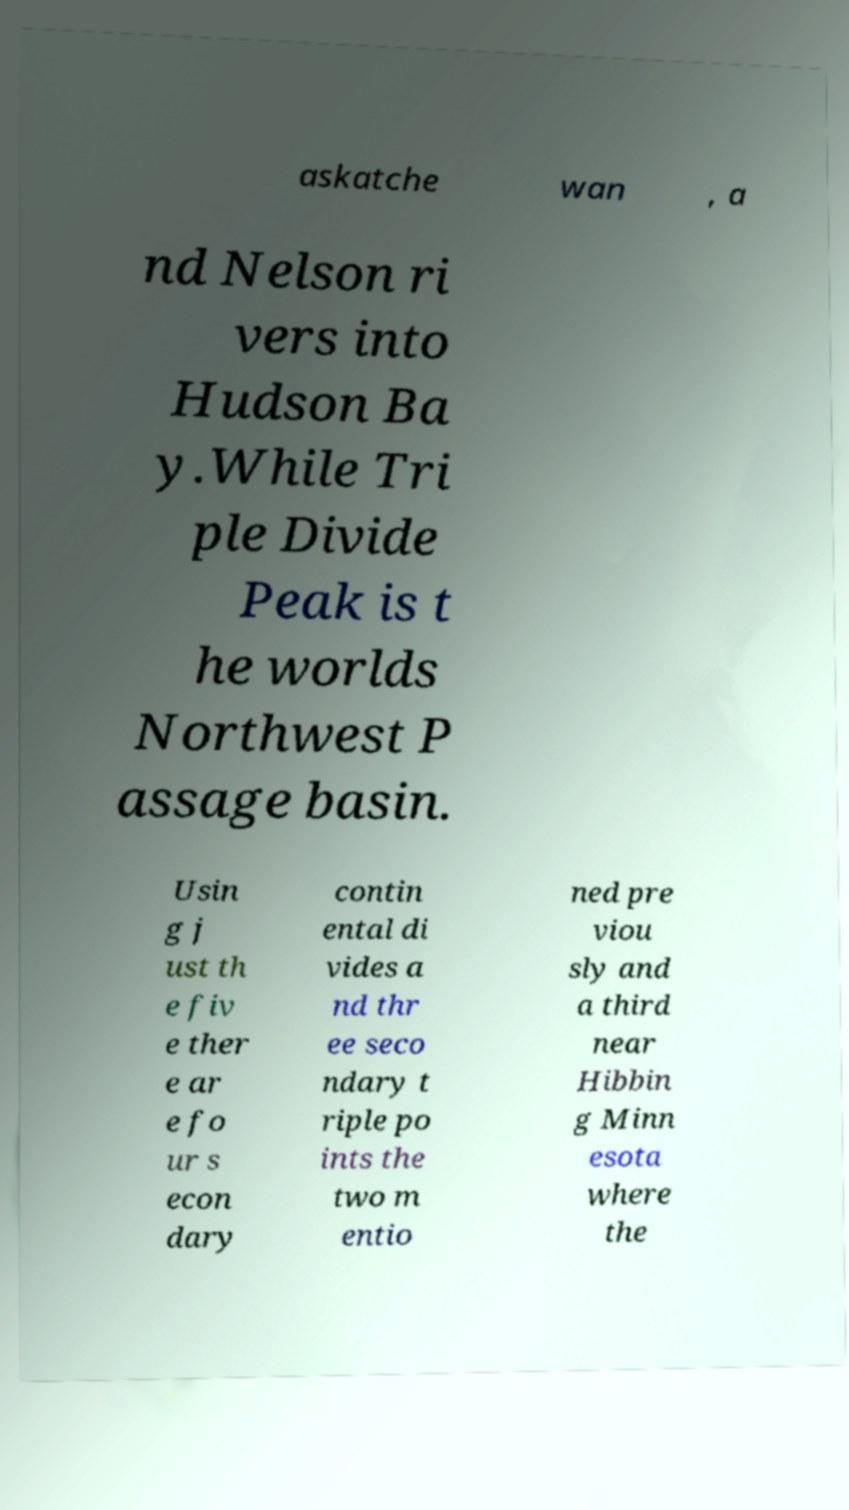There's text embedded in this image that I need extracted. Can you transcribe it verbatim? askatche wan , a nd Nelson ri vers into Hudson Ba y.While Tri ple Divide Peak is t he worlds Northwest P assage basin. Usin g j ust th e fiv e ther e ar e fo ur s econ dary contin ental di vides a nd thr ee seco ndary t riple po ints the two m entio ned pre viou sly and a third near Hibbin g Minn esota where the 